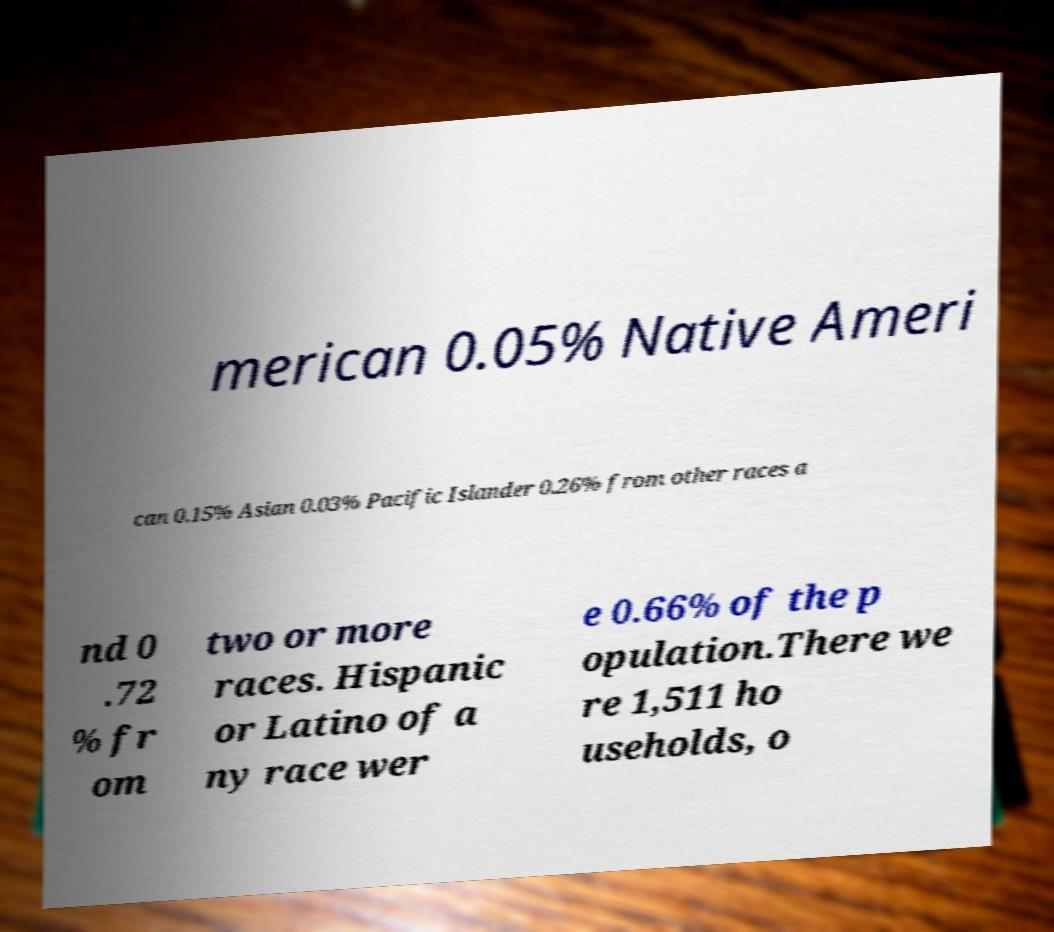Can you read and provide the text displayed in the image?This photo seems to have some interesting text. Can you extract and type it out for me? merican 0.05% Native Ameri can 0.15% Asian 0.03% Pacific Islander 0.26% from other races a nd 0 .72 % fr om two or more races. Hispanic or Latino of a ny race wer e 0.66% of the p opulation.There we re 1,511 ho useholds, o 